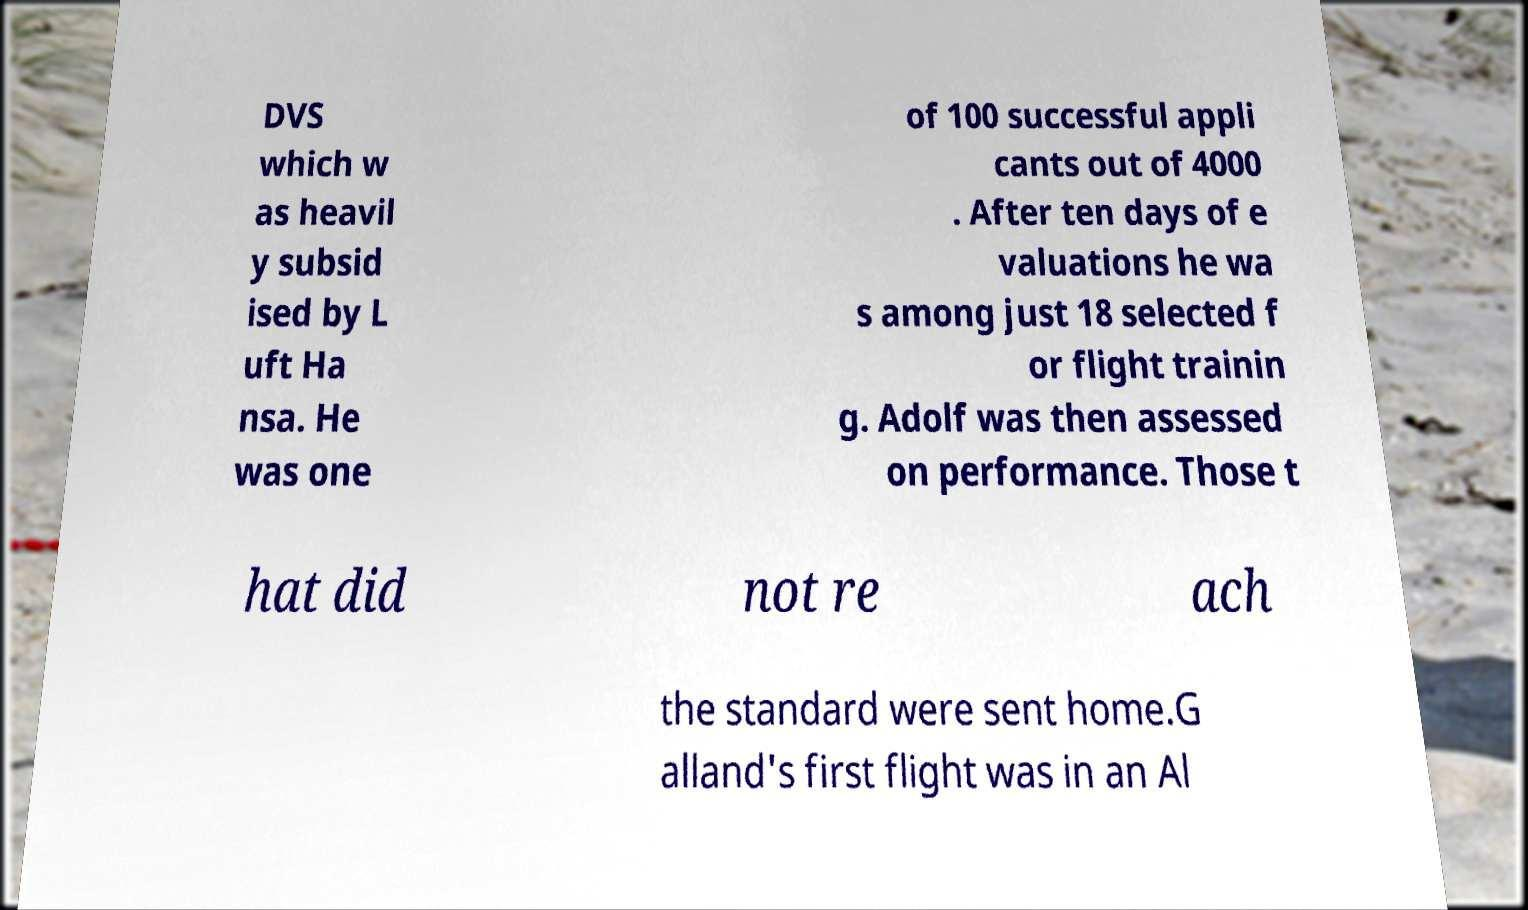For documentation purposes, I need the text within this image transcribed. Could you provide that? DVS which w as heavil y subsid ised by L uft Ha nsa. He was one of 100 successful appli cants out of 4000 . After ten days of e valuations he wa s among just 18 selected f or flight trainin g. Adolf was then assessed on performance. Those t hat did not re ach the standard were sent home.G alland's first flight was in an Al 